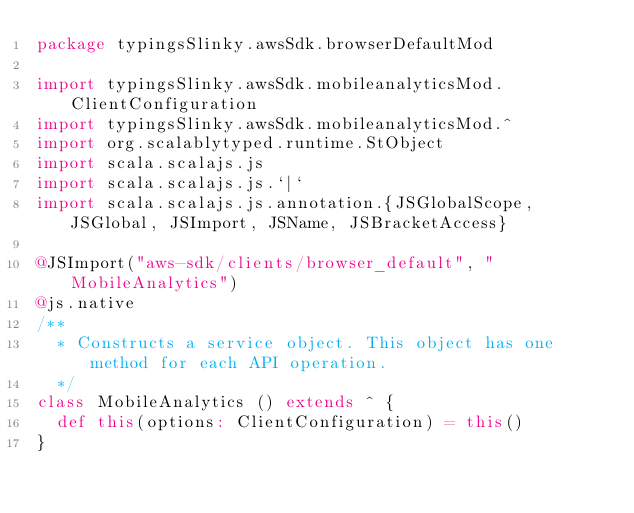<code> <loc_0><loc_0><loc_500><loc_500><_Scala_>package typingsSlinky.awsSdk.browserDefaultMod

import typingsSlinky.awsSdk.mobileanalyticsMod.ClientConfiguration
import typingsSlinky.awsSdk.mobileanalyticsMod.^
import org.scalablytyped.runtime.StObject
import scala.scalajs.js
import scala.scalajs.js.`|`
import scala.scalajs.js.annotation.{JSGlobalScope, JSGlobal, JSImport, JSName, JSBracketAccess}

@JSImport("aws-sdk/clients/browser_default", "MobileAnalytics")
@js.native
/**
  * Constructs a service object. This object has one method for each API operation.
  */
class MobileAnalytics () extends ^ {
  def this(options: ClientConfiguration) = this()
}
</code> 